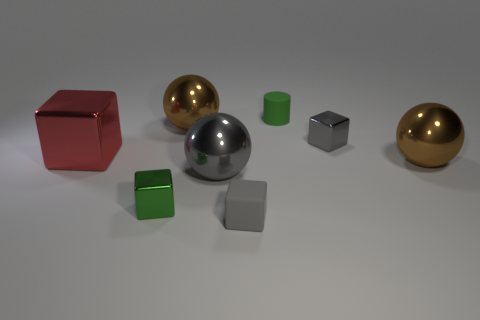Subtract all big gray spheres. How many spheres are left? 2 Add 2 rubber objects. How many objects exist? 10 Subtract 2 cubes. How many cubes are left? 2 Subtract all gray cubes. How many cubes are left? 2 Subtract all spheres. How many objects are left? 5 Subtract all yellow cylinders. How many yellow balls are left? 0 Subtract 0 yellow spheres. How many objects are left? 8 Subtract all red balls. Subtract all yellow cylinders. How many balls are left? 3 Subtract all purple metallic objects. Subtract all cylinders. How many objects are left? 7 Add 3 green rubber things. How many green rubber things are left? 4 